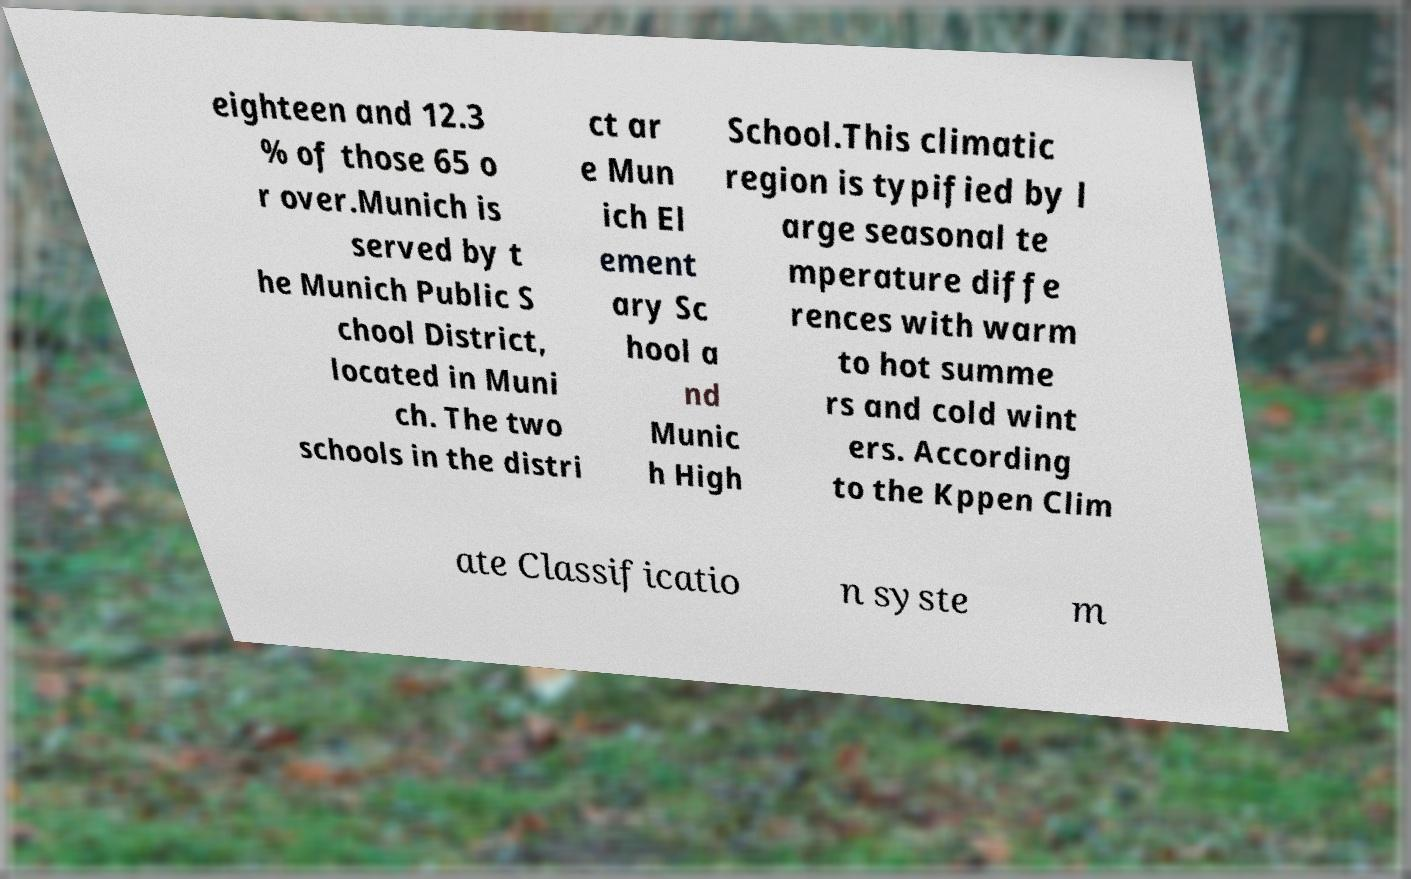Can you accurately transcribe the text from the provided image for me? eighteen and 12.3 % of those 65 o r over.Munich is served by t he Munich Public S chool District, located in Muni ch. The two schools in the distri ct ar e Mun ich El ement ary Sc hool a nd Munic h High School.This climatic region is typified by l arge seasonal te mperature diffe rences with warm to hot summe rs and cold wint ers. According to the Kppen Clim ate Classificatio n syste m 